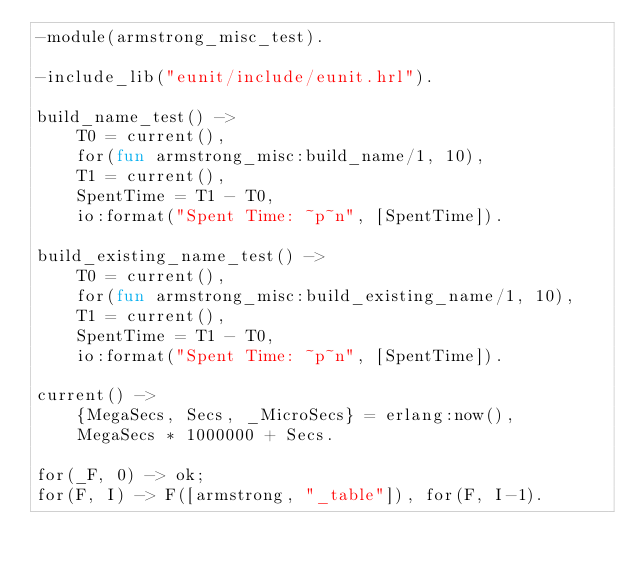<code> <loc_0><loc_0><loc_500><loc_500><_Erlang_>-module(armstrong_misc_test).

-include_lib("eunit/include/eunit.hrl").

build_name_test() ->
    T0 = current(),
    for(fun armstrong_misc:build_name/1, 10),
    T1 = current(),
    SpentTime = T1 - T0,
    io:format("Spent Time: ~p~n", [SpentTime]).

build_existing_name_test() ->
    T0 = current(),
    for(fun armstrong_misc:build_existing_name/1, 10),
    T1 = current(),
    SpentTime = T1 - T0,
    io:format("Spent Time: ~p~n", [SpentTime]).

current() ->
    {MegaSecs, Secs, _MicroSecs} = erlang:now(),
    MegaSecs * 1000000 + Secs.

for(_F, 0) -> ok;
for(F, I) -> F([armstrong, "_table"]), for(F, I-1).


</code> 